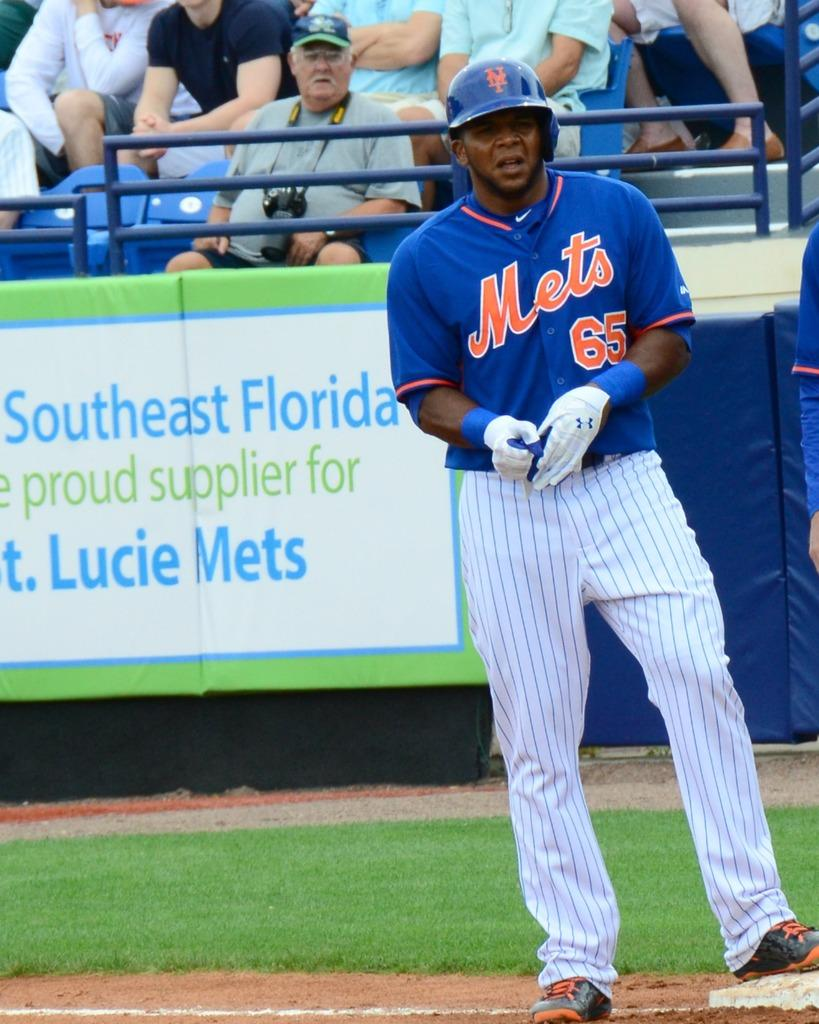<image>
Write a terse but informative summary of the picture. A Mets player wearing number 65 stands at first base during a baseball game. 